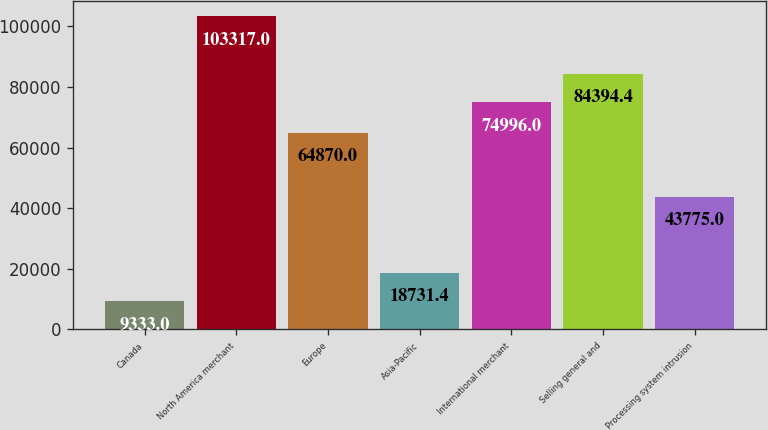Convert chart. <chart><loc_0><loc_0><loc_500><loc_500><bar_chart><fcel>Canada<fcel>North America merchant<fcel>Europe<fcel>Asia-Pacific<fcel>International merchant<fcel>Selling general and<fcel>Processing system intrusion<nl><fcel>9333<fcel>103317<fcel>64870<fcel>18731.4<fcel>74996<fcel>84394.4<fcel>43775<nl></chart> 